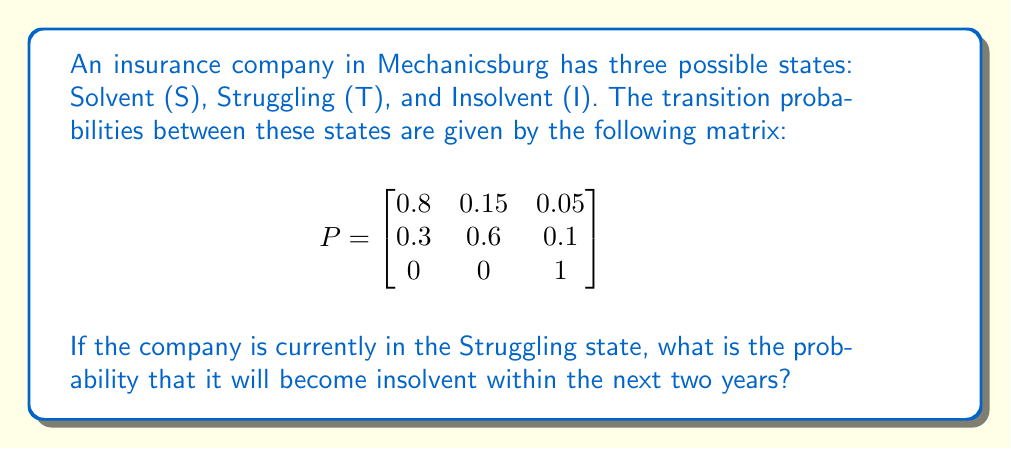Teach me how to tackle this problem. To solve this problem, we need to use the properties of Markov chains:

1. First, we identify the initial state: Struggling (T)

2. We need to calculate the probability of reaching the Insolvent state (I) in either one or two steps.

3. For one step:
   P(T to I in 1 step) = $P_{TI} = 0.1$

4. For two steps, we need to consider all possible paths:
   a) T to T to I
   b) T to S to I

5. Calculate the probabilities:
   P(T to T to I) = $P_{TT} \cdot P_{TI} = 0.6 \cdot 0.1 = 0.06$
   P(T to S to I) = $P_{TS} \cdot P_{SI} = 0.3 \cdot 0.05 = 0.015$

6. Sum up all probabilities:
   Total probability = P(1 step) + P(2 steps)
                     = 0.1 + (0.06 + 0.015)
                     = 0.1 + 0.075
                     = 0.175

Therefore, the probability of the company becoming insolvent within the next two years, starting from the Struggling state, is 0.175 or 17.5%.
Answer: 0.175 